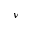<formula> <loc_0><loc_0><loc_500><loc_500>\nu</formula> 